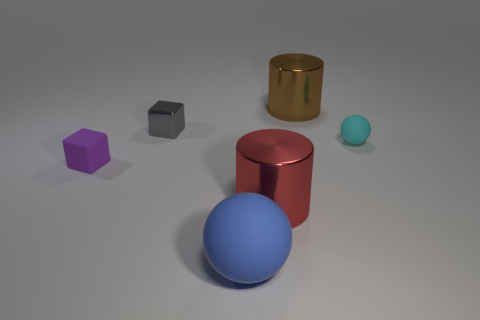Add 1 large brown objects. How many objects exist? 7 Subtract all cylinders. How many objects are left? 4 Add 6 red shiny things. How many red shiny things are left? 7 Add 1 small red metallic blocks. How many small red metallic blocks exist? 1 Subtract 1 purple blocks. How many objects are left? 5 Subtract all small purple cylinders. Subtract all big brown metallic objects. How many objects are left? 5 